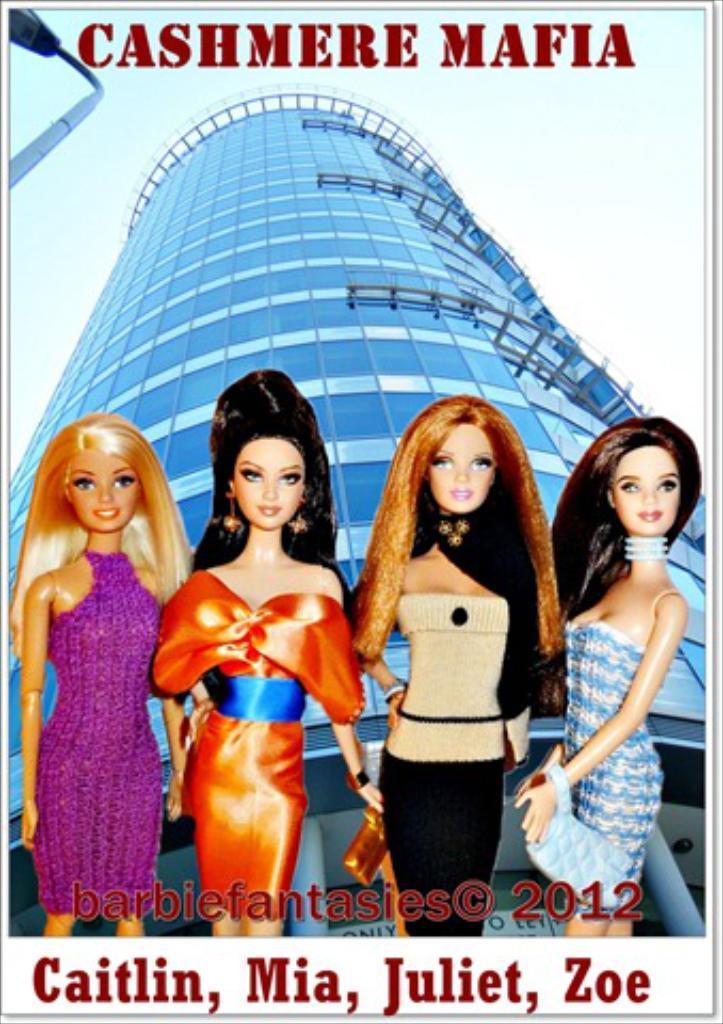Describe this image in one or two sentences. This is the picture of a poster in which there are four girls and behind there is a building and some things written around. 